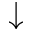Convert formula to latex. <formula><loc_0><loc_0><loc_500><loc_500>\downarrow</formula> 